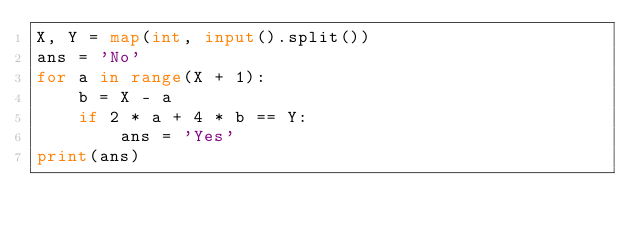<code> <loc_0><loc_0><loc_500><loc_500><_Python_>X, Y = map(int, input().split())
ans = 'No'
for a in range(X + 1):
	b = X - a
	if 2 * a + 4 * b == Y:
		ans = 'Yes'
print(ans)</code> 